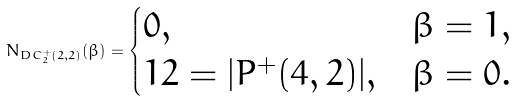<formula> <loc_0><loc_0><loc_500><loc_500>N _ { D C _ { 2 } ^ { + } ( 2 , 2 ) } ( \beta ) = \begin{cases} 0 , & \beta = 1 , \\ 1 2 = | P ^ { + } ( 4 , 2 ) | , & \beta = 0 . \end{cases}</formula> 